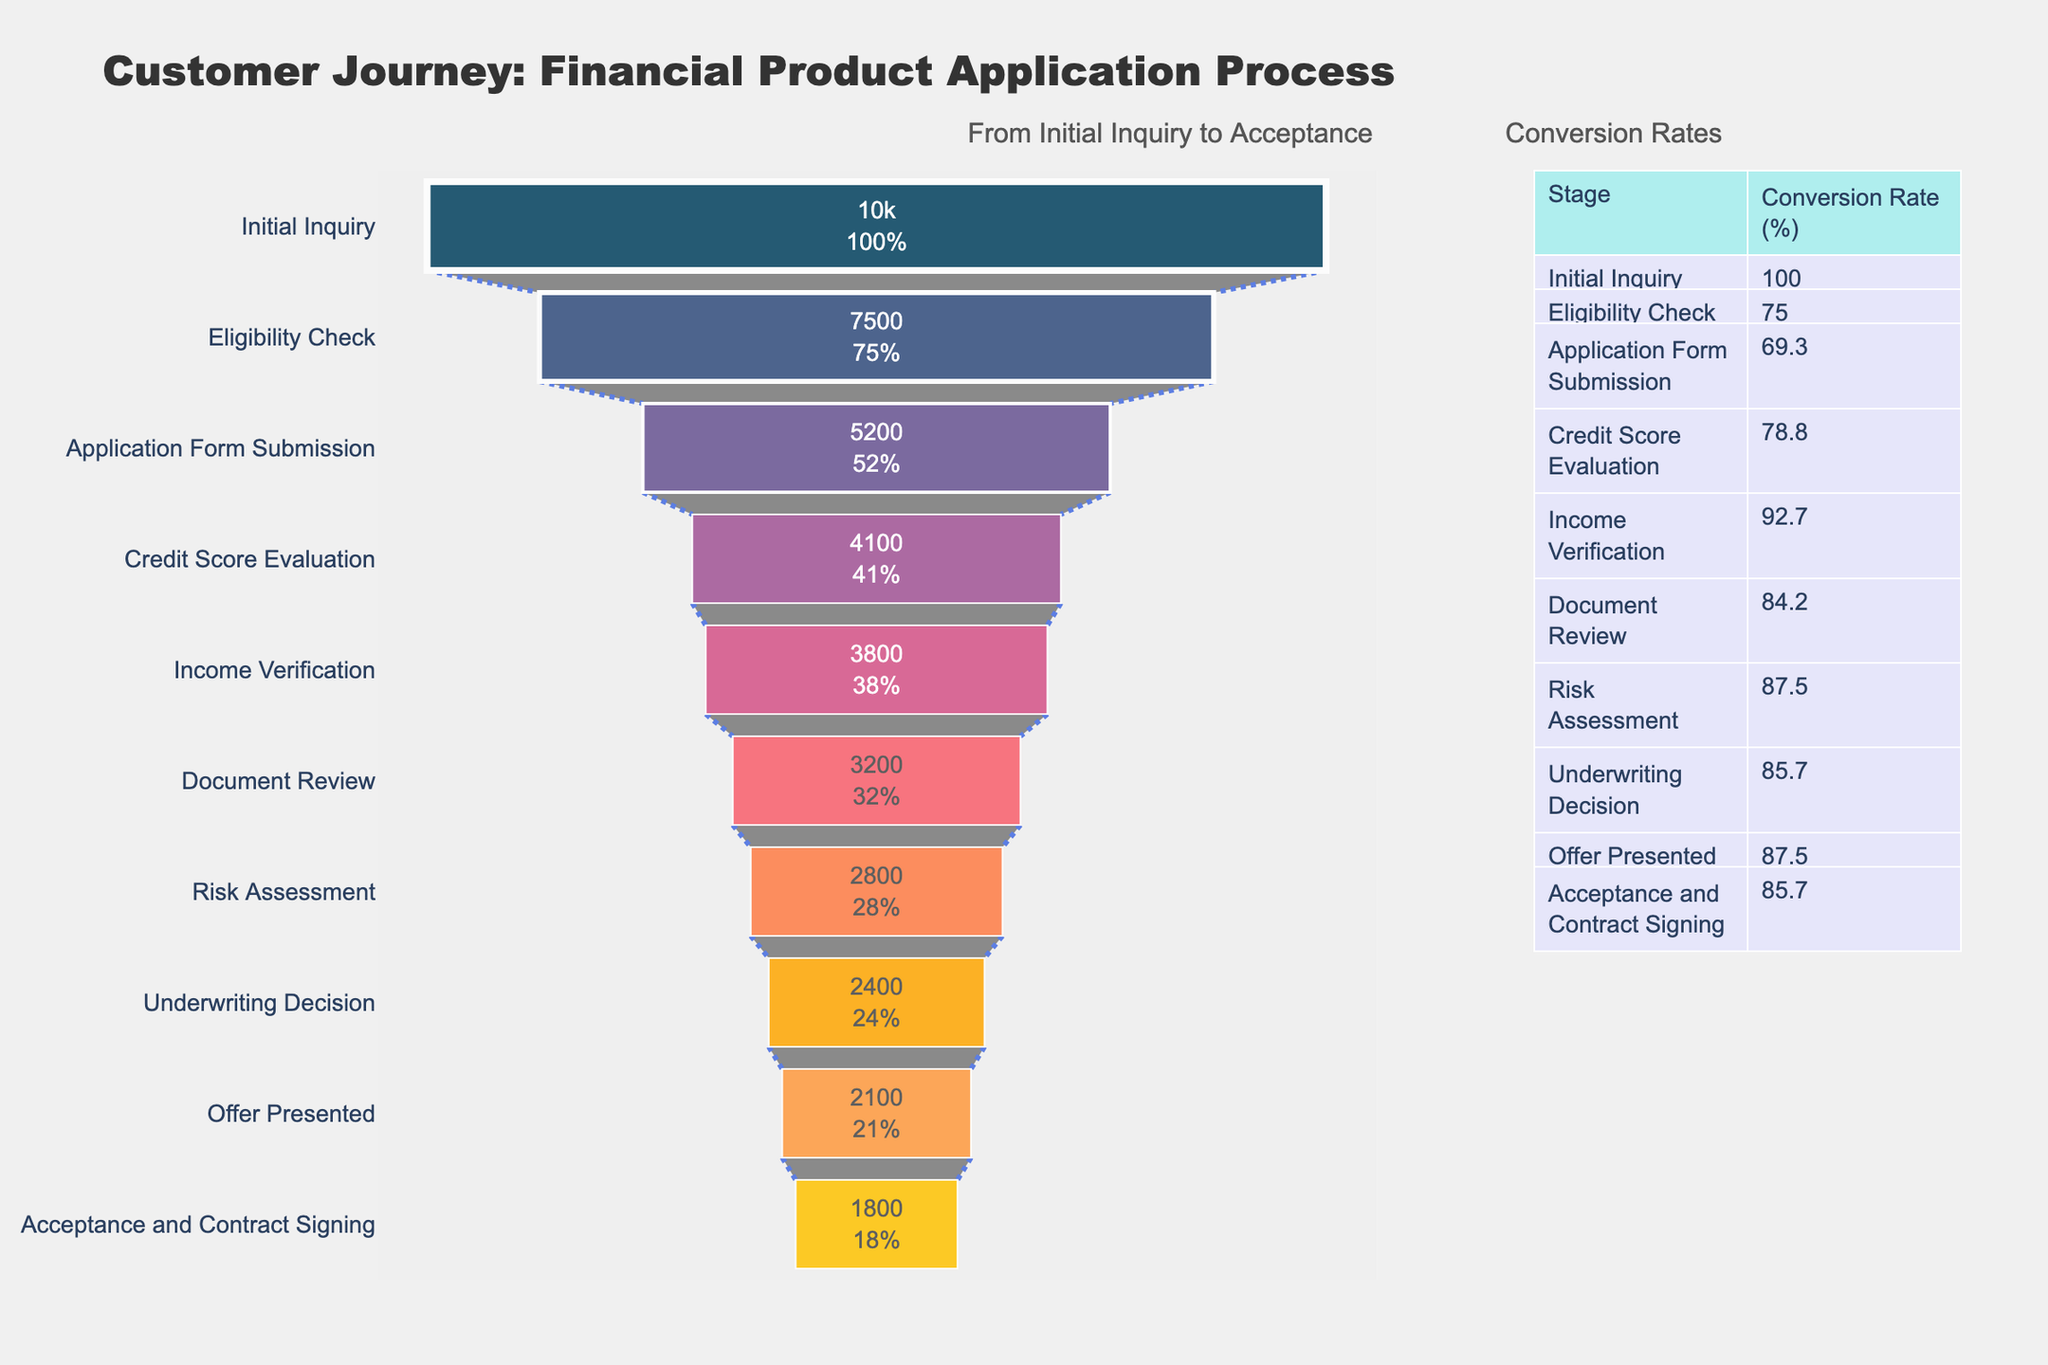What is the title of the figure? The title is located at the top of the figure and provides a summary of what the figure represents.
Answer: Customer Journey: Financial Product Application Process Which stage has the highest number of applicants? The highest number of applicants appears at the top of the funnel chart.
Answer: Initial Inquiry What is the conversion rate from 'Initial Inquiry' to 'Eligibility Check'? The conversion rate is given in the conversion rate table associated with the figure. For 'Initial Inquiry' to 'Eligibility Check', it is 75%.
Answer: 75% At which stage do you see the first significant drop in the number of applicants? By comparing the number of applicants at each stage, the first significant drop can be noticed. From 'Eligibility Check' (7500) to 'Application Form Submission' (5200), the number of applicants drops significantly.
Answer: Application Form Submission Which stage shows the most significant drop in the conversion rate? To find the stage with the most significant drop, look at the conversion rates. The largest drop is from 'Income Verification' to 'Document Review' (from 92.7% to 84.2%).
Answer: Income Verification to Document Review What is the difference in applicant numbers between 'Credit Score Evaluation' and 'Income Verification'? The number of applicants at 'Credit Score Evaluation' is 4100, and at 'Income Verification' it is 3800. By subtracting 3800 from 4100, the difference is 300 applicants.
Answer: 300 Which color represents the 'Underwriting Decision' stage in the funnel chart? Each stage in the funnel chart has a specific color, and 'Underwriting Decision' is represented by an orange to yellow gradient color.
Answer: Orange to Yellow How many applicants were lost between 'Offer Presented' and 'Acceptance and Contract Signing'? The number of applicants at 'Offer Presented' is 2100 and at 'Acceptance and Contract Signing' is 1800. Subtracting 1800 from 2100 gives the number of lost applicants, which is 300.
Answer: 300 Compare the conversion rates between 'Document Review' and 'Risk Assessment'. Which one is higher? The conversion rate for 'Document Review' is 84.2%, and for 'Risk Assessment', it is 87.5%. Therefore, 'Risk Assessment' has a higher conversion rate.
Answer: Risk Assessment Which stage comes after 'Risk Assessment' in the funnel chart? Following the logical sequence of the stages in the funnel chart, the stage after 'Risk Assessment' is 'Underwriting Decision'.
Answer: Underwriting Decision 